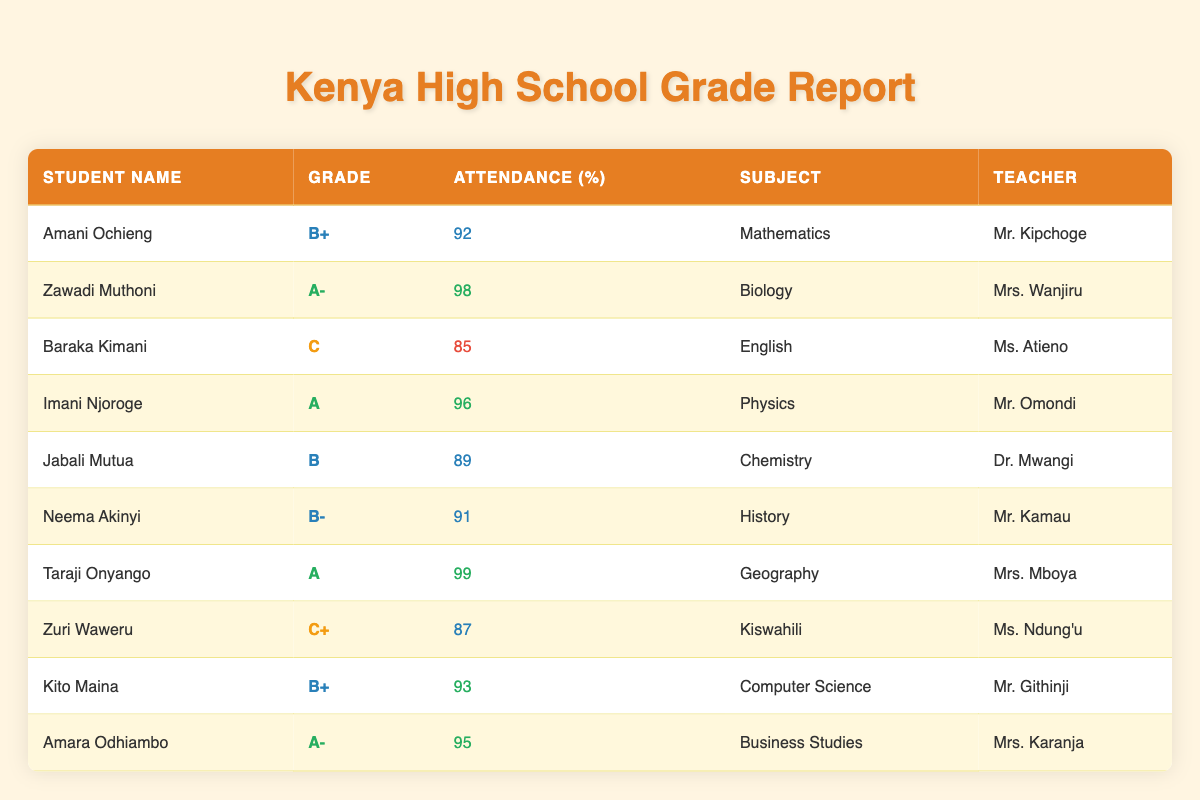What is the highest attendance percentage recorded? The attendance percentages in the table are 92, 98, 85, 96, 89, 91, 99, 87, 93, and 95. By comparing these values, the highest is 99.
Answer: 99 Which student has the lowest grade? The grades in the table are B+, A-, C, A, B, B-, A, C+, B+, and A-. The lowest grade is C, which belongs to Baraka Kimani.
Answer: Baraka Kimani How many students have an attendance percentage of 90% or above? The attendance percentages that meet this criterion are 92, 98, 96, 99, 91, and 93, making a total of 6 students.
Answer: 6 Is Zawadi Muthoni's grade higher than Imani Njoroge's grade? Zawadi Muthoni has an A- and Imani Njoroge has an A. Since A is higher than A-, the answer is no.
Answer: No What is the average attendance percentage of students with a grade of B or lower? The students with a grade of B or lower are Baraka Kimani (85), Jabali Mutua (89), Neema Akinyi (91), Zuri Waweru (87), which gives us four attendance percentages to average: (85 + 89 + 91 + 87) = 352, then divide by 4 to get 88.
Answer: 88 Which subject is taught by the teacher that has the highest performing student in terms of attendance? The highest attendance is 99, attributed to Taraji Onyango in Geography. So the subject is Geography.
Answer: Geography How many students earned a grade of A? The students who earned a grade of A are Imani Njoroge and Taraji Onyango, totaling 2 students.
Answer: 2 Is Amara Odhiambo's attendance higher than Kito Maina's attendance? Amara Odhiambo has an attendance of 95 while Kito Maina has 93. Since 95 is greater than 93, the answer is yes.
Answer: Yes 